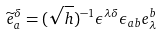<formula> <loc_0><loc_0><loc_500><loc_500>\widetilde { e } ^ { \delta } _ { a } = ( \sqrt { h } ) ^ { - 1 } \epsilon ^ { \lambda \delta } \epsilon _ { a b } e ^ { b } _ { \lambda }</formula> 